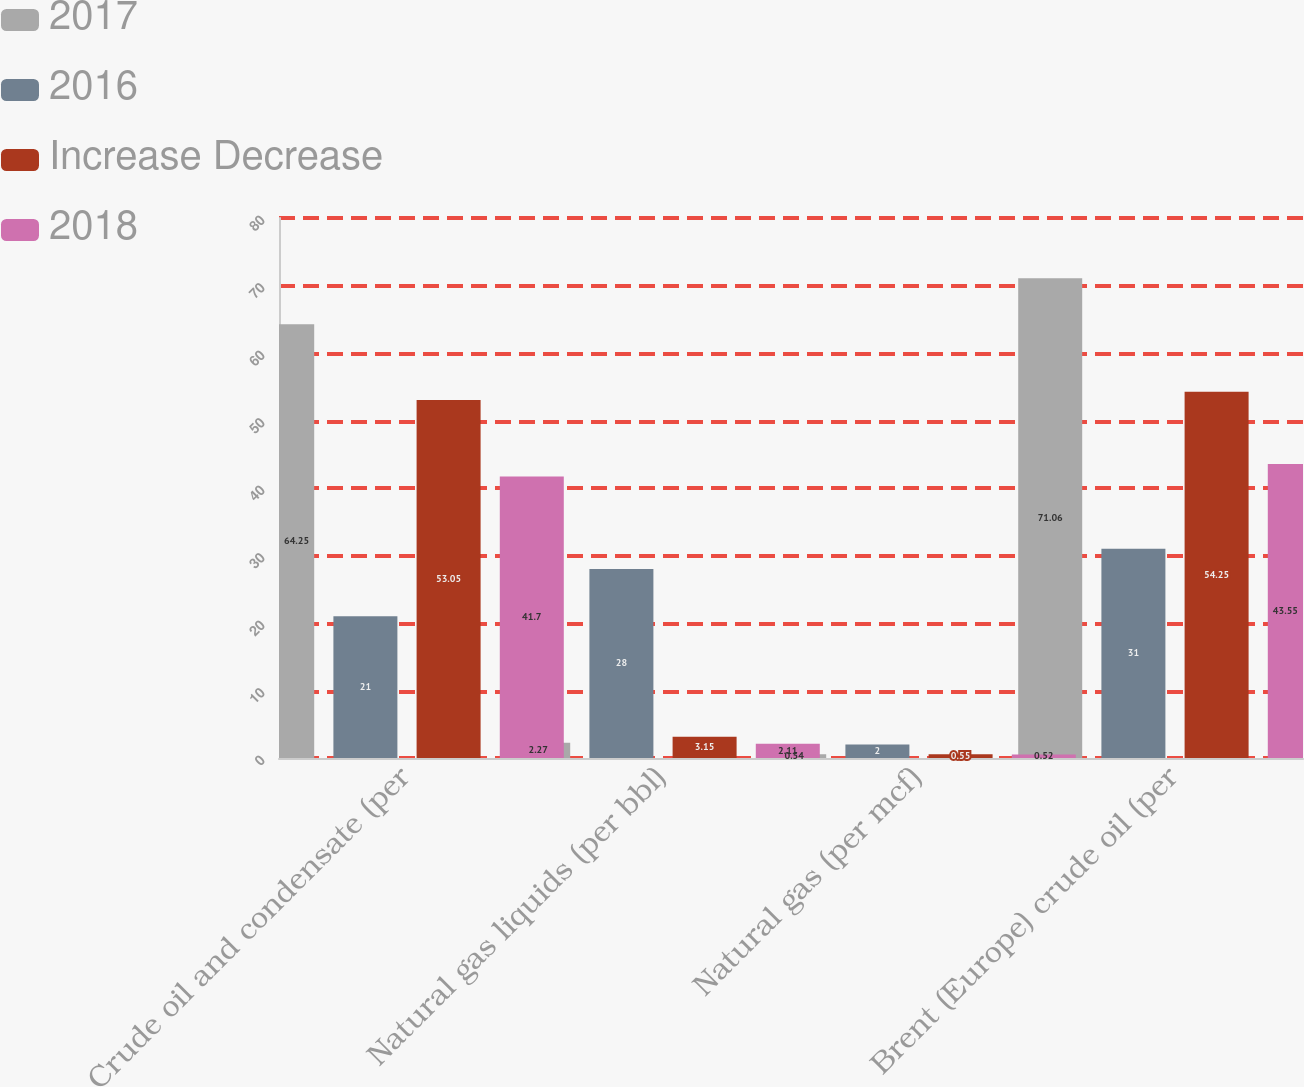<chart> <loc_0><loc_0><loc_500><loc_500><stacked_bar_chart><ecel><fcel>Crude oil and condensate (per<fcel>Natural gas liquids (per bbl)<fcel>Natural gas (per mcf)<fcel>Brent (Europe) crude oil (per<nl><fcel>2017<fcel>64.25<fcel>2.27<fcel>0.54<fcel>71.06<nl><fcel>2016<fcel>21<fcel>28<fcel>2<fcel>31<nl><fcel>Increase Decrease<fcel>53.05<fcel>3.15<fcel>0.55<fcel>54.25<nl><fcel>2018<fcel>41.7<fcel>2.11<fcel>0.52<fcel>43.55<nl></chart> 